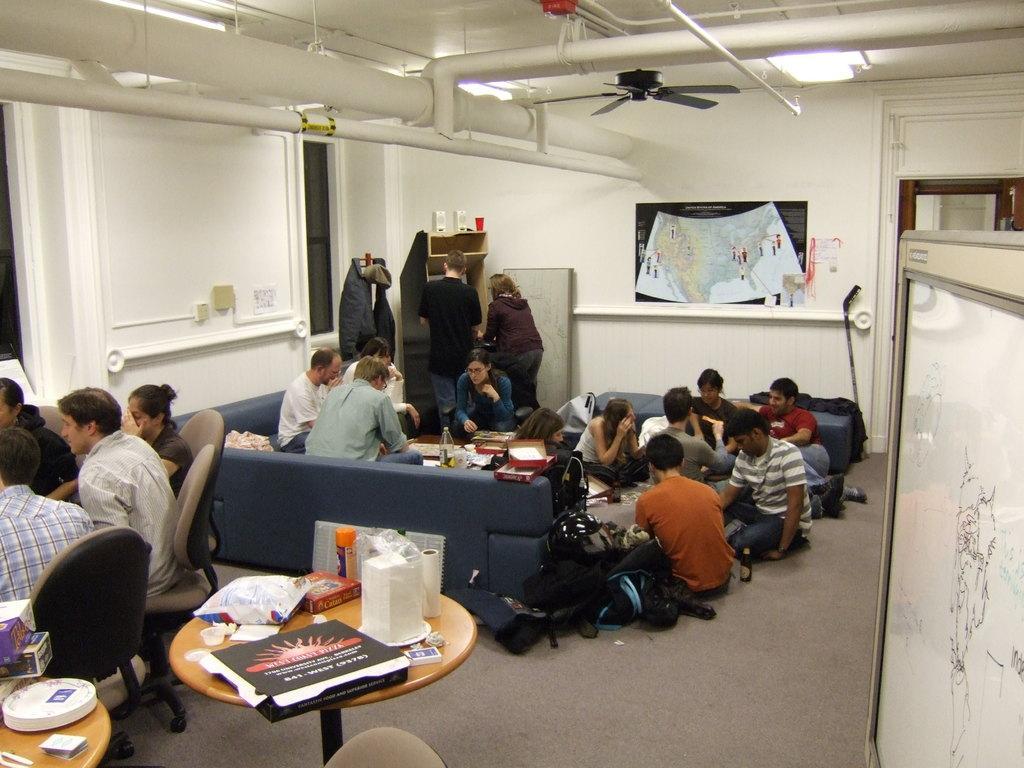Please provide a concise description of this image. This image is clicked in a room. There is a sofa in the middle and there is a table, on the table there is a paper, cover. There are people sitting on the sofa the and chair. There is a light and fan on the top. 